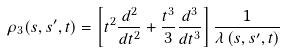Convert formula to latex. <formula><loc_0><loc_0><loc_500><loc_500>\rho _ { 3 } ( s , s ^ { \prime } , t ) = \left [ t ^ { 2 } \frac { d ^ { 2 } } { d t ^ { 2 } } + \frac { t ^ { 3 } } { 3 } \frac { d ^ { 3 } } { d t ^ { 3 } } \right ] \frac { 1 } { \lambda \left ( s , s ^ { \prime } , t \right ) }</formula> 